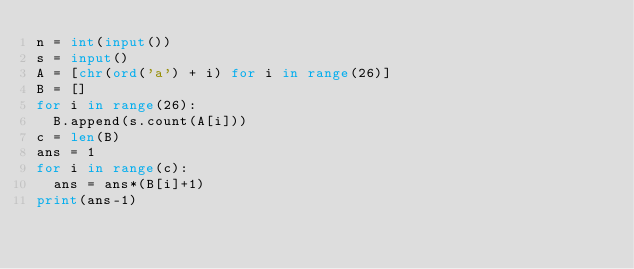<code> <loc_0><loc_0><loc_500><loc_500><_Python_>n = int(input())
s = input()
A = [chr(ord('a') + i) for i in range(26)]
B = []
for i in range(26):
  B.append(s.count(A[i]))
c = len(B)
ans = 1
for i in range(c):
  ans = ans*(B[i]+1)
print(ans-1)</code> 